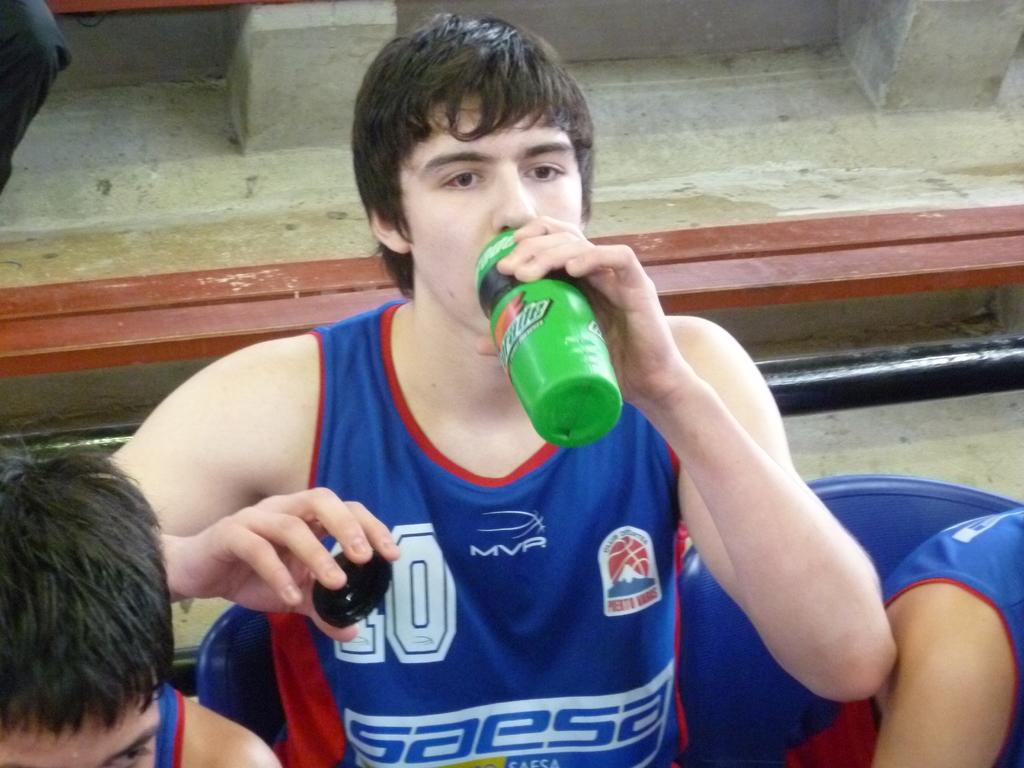<image>
Give a short and clear explanation of the subsequent image. A basketball player is drinking from a green Gatorade branded sports bottle. 